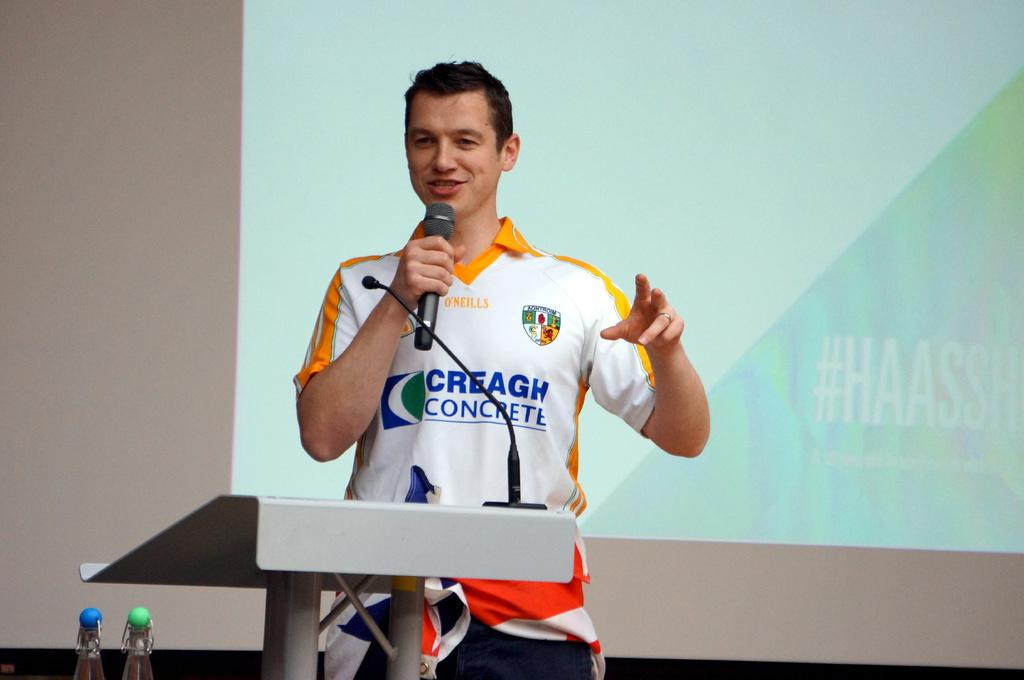<image>
Give a short and clear explanation of the subsequent image. a jersey that has the word concrete on it 